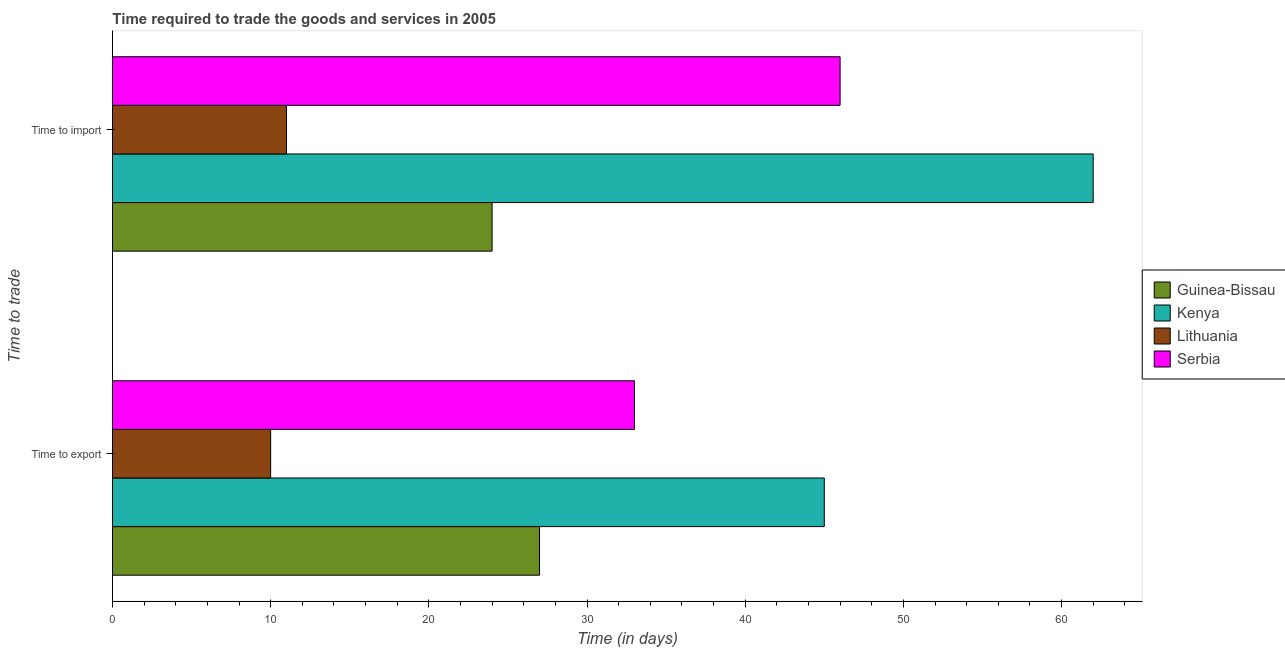How many groups of bars are there?
Make the answer very short. 2. How many bars are there on the 2nd tick from the bottom?
Offer a very short reply. 4. What is the label of the 2nd group of bars from the top?
Your response must be concise. Time to export. What is the time to export in Kenya?
Your response must be concise. 45. Across all countries, what is the maximum time to export?
Provide a short and direct response. 45. Across all countries, what is the minimum time to export?
Give a very brief answer. 10. In which country was the time to import maximum?
Make the answer very short. Kenya. In which country was the time to import minimum?
Give a very brief answer. Lithuania. What is the total time to import in the graph?
Make the answer very short. 143. What is the difference between the time to export in Guinea-Bissau and that in Kenya?
Offer a very short reply. -18. What is the difference between the time to import in Guinea-Bissau and the time to export in Serbia?
Make the answer very short. -9. What is the average time to export per country?
Offer a terse response. 28.75. What is the difference between the time to import and time to export in Guinea-Bissau?
Offer a terse response. -3. What is the ratio of the time to export in Lithuania to that in Serbia?
Keep it short and to the point. 0.3. In how many countries, is the time to export greater than the average time to export taken over all countries?
Your answer should be very brief. 2. What does the 2nd bar from the top in Time to export represents?
Ensure brevity in your answer.  Lithuania. What does the 2nd bar from the bottom in Time to export represents?
Ensure brevity in your answer.  Kenya. How many bars are there?
Give a very brief answer. 8. Are the values on the major ticks of X-axis written in scientific E-notation?
Keep it short and to the point. No. Does the graph contain grids?
Ensure brevity in your answer.  No. Where does the legend appear in the graph?
Keep it short and to the point. Center right. How are the legend labels stacked?
Provide a short and direct response. Vertical. What is the title of the graph?
Your response must be concise. Time required to trade the goods and services in 2005. What is the label or title of the X-axis?
Make the answer very short. Time (in days). What is the label or title of the Y-axis?
Offer a very short reply. Time to trade. What is the Time (in days) of Lithuania in Time to import?
Offer a terse response. 11. Across all Time to trade, what is the maximum Time (in days) in Lithuania?
Offer a very short reply. 11. Across all Time to trade, what is the minimum Time (in days) of Guinea-Bissau?
Provide a succinct answer. 24. Across all Time to trade, what is the minimum Time (in days) of Serbia?
Provide a short and direct response. 33. What is the total Time (in days) in Kenya in the graph?
Your answer should be very brief. 107. What is the total Time (in days) of Serbia in the graph?
Offer a very short reply. 79. What is the difference between the Time (in days) in Lithuania in Time to export and that in Time to import?
Your answer should be very brief. -1. What is the difference between the Time (in days) of Guinea-Bissau in Time to export and the Time (in days) of Kenya in Time to import?
Make the answer very short. -35. What is the difference between the Time (in days) in Guinea-Bissau in Time to export and the Time (in days) in Serbia in Time to import?
Your answer should be compact. -19. What is the difference between the Time (in days) in Kenya in Time to export and the Time (in days) in Lithuania in Time to import?
Provide a short and direct response. 34. What is the difference between the Time (in days) of Kenya in Time to export and the Time (in days) of Serbia in Time to import?
Offer a very short reply. -1. What is the difference between the Time (in days) in Lithuania in Time to export and the Time (in days) in Serbia in Time to import?
Offer a terse response. -36. What is the average Time (in days) of Guinea-Bissau per Time to trade?
Ensure brevity in your answer.  25.5. What is the average Time (in days) of Kenya per Time to trade?
Your response must be concise. 53.5. What is the average Time (in days) of Serbia per Time to trade?
Your answer should be compact. 39.5. What is the difference between the Time (in days) in Guinea-Bissau and Time (in days) in Kenya in Time to export?
Provide a short and direct response. -18. What is the difference between the Time (in days) in Lithuania and Time (in days) in Serbia in Time to export?
Provide a short and direct response. -23. What is the difference between the Time (in days) in Guinea-Bissau and Time (in days) in Kenya in Time to import?
Offer a very short reply. -38. What is the difference between the Time (in days) of Guinea-Bissau and Time (in days) of Lithuania in Time to import?
Offer a very short reply. 13. What is the difference between the Time (in days) of Guinea-Bissau and Time (in days) of Serbia in Time to import?
Your answer should be very brief. -22. What is the difference between the Time (in days) in Kenya and Time (in days) in Lithuania in Time to import?
Your answer should be very brief. 51. What is the difference between the Time (in days) of Lithuania and Time (in days) of Serbia in Time to import?
Your answer should be very brief. -35. What is the ratio of the Time (in days) in Kenya in Time to export to that in Time to import?
Offer a very short reply. 0.73. What is the ratio of the Time (in days) of Serbia in Time to export to that in Time to import?
Make the answer very short. 0.72. What is the difference between the highest and the second highest Time (in days) in Guinea-Bissau?
Offer a terse response. 3. What is the difference between the highest and the second highest Time (in days) of Lithuania?
Make the answer very short. 1. What is the difference between the highest and the second highest Time (in days) of Serbia?
Provide a succinct answer. 13. What is the difference between the highest and the lowest Time (in days) of Guinea-Bissau?
Offer a terse response. 3. 